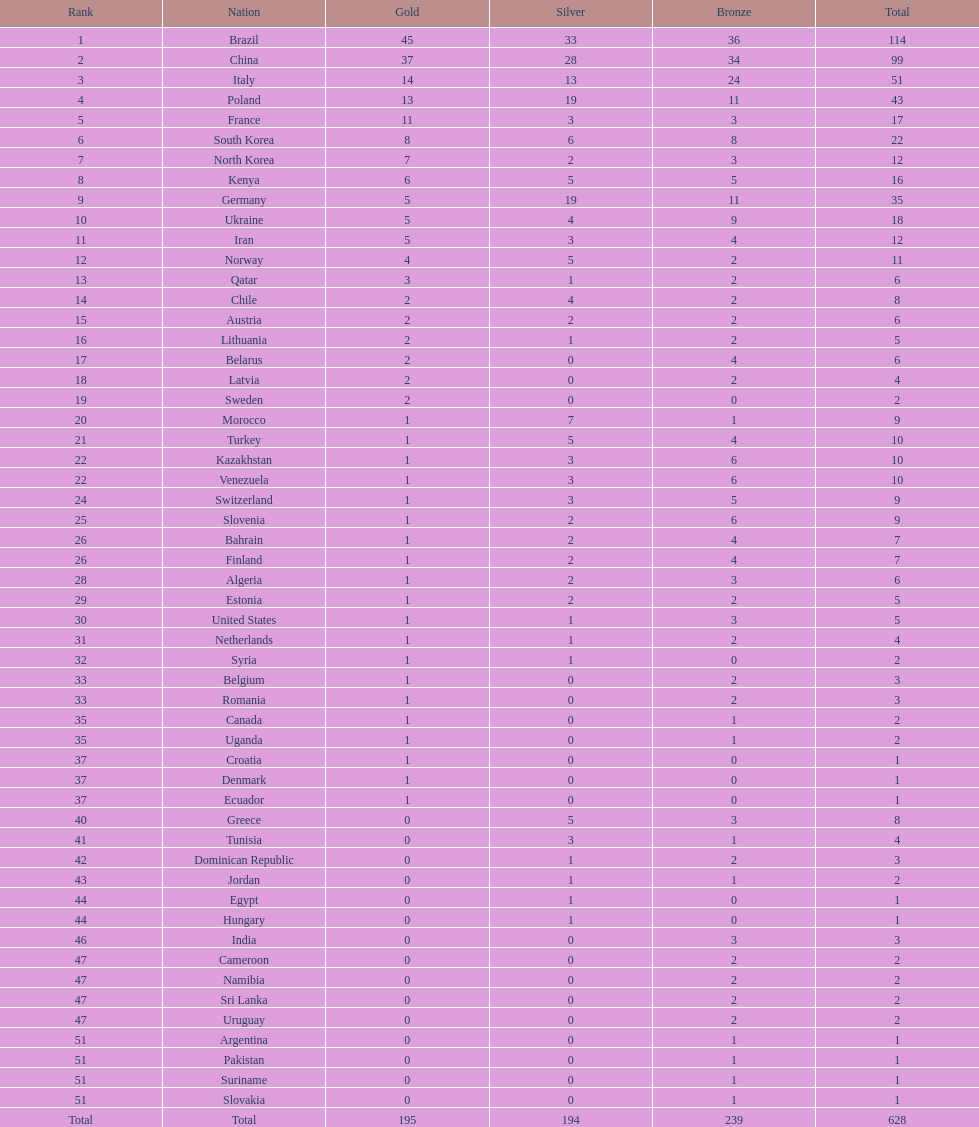How many medals have south korea, north korea, sweden, and brazil collectively won? 150. Write the full table. {'header': ['Rank', 'Nation', 'Gold', 'Silver', 'Bronze', 'Total'], 'rows': [['1', 'Brazil', '45', '33', '36', '114'], ['2', 'China', '37', '28', '34', '99'], ['3', 'Italy', '14', '13', '24', '51'], ['4', 'Poland', '13', '19', '11', '43'], ['5', 'France', '11', '3', '3', '17'], ['6', 'South Korea', '8', '6', '8', '22'], ['7', 'North Korea', '7', '2', '3', '12'], ['8', 'Kenya', '6', '5', '5', '16'], ['9', 'Germany', '5', '19', '11', '35'], ['10', 'Ukraine', '5', '4', '9', '18'], ['11', 'Iran', '5', '3', '4', '12'], ['12', 'Norway', '4', '5', '2', '11'], ['13', 'Qatar', '3', '1', '2', '6'], ['14', 'Chile', '2', '4', '2', '8'], ['15', 'Austria', '2', '2', '2', '6'], ['16', 'Lithuania', '2', '1', '2', '5'], ['17', 'Belarus', '2', '0', '4', '6'], ['18', 'Latvia', '2', '0', '2', '4'], ['19', 'Sweden', '2', '0', '0', '2'], ['20', 'Morocco', '1', '7', '1', '9'], ['21', 'Turkey', '1', '5', '4', '10'], ['22', 'Kazakhstan', '1', '3', '6', '10'], ['22', 'Venezuela', '1', '3', '6', '10'], ['24', 'Switzerland', '1', '3', '5', '9'], ['25', 'Slovenia', '1', '2', '6', '9'], ['26', 'Bahrain', '1', '2', '4', '7'], ['26', 'Finland', '1', '2', '4', '7'], ['28', 'Algeria', '1', '2', '3', '6'], ['29', 'Estonia', '1', '2', '2', '5'], ['30', 'United States', '1', '1', '3', '5'], ['31', 'Netherlands', '1', '1', '2', '4'], ['32', 'Syria', '1', '1', '0', '2'], ['33', 'Belgium', '1', '0', '2', '3'], ['33', 'Romania', '1', '0', '2', '3'], ['35', 'Canada', '1', '0', '1', '2'], ['35', 'Uganda', '1', '0', '1', '2'], ['37', 'Croatia', '1', '0', '0', '1'], ['37', 'Denmark', '1', '0', '0', '1'], ['37', 'Ecuador', '1', '0', '0', '1'], ['40', 'Greece', '0', '5', '3', '8'], ['41', 'Tunisia', '0', '3', '1', '4'], ['42', 'Dominican Republic', '0', '1', '2', '3'], ['43', 'Jordan', '0', '1', '1', '2'], ['44', 'Egypt', '0', '1', '0', '1'], ['44', 'Hungary', '0', '1', '0', '1'], ['46', 'India', '0', '0', '3', '3'], ['47', 'Cameroon', '0', '0', '2', '2'], ['47', 'Namibia', '0', '0', '2', '2'], ['47', 'Sri Lanka', '0', '0', '2', '2'], ['47', 'Uruguay', '0', '0', '2', '2'], ['51', 'Argentina', '0', '0', '1', '1'], ['51', 'Pakistan', '0', '0', '1', '1'], ['51', 'Suriname', '0', '0', '1', '1'], ['51', 'Slovakia', '0', '0', '1', '1'], ['Total', 'Total', '195', '194', '239', '628']]} 